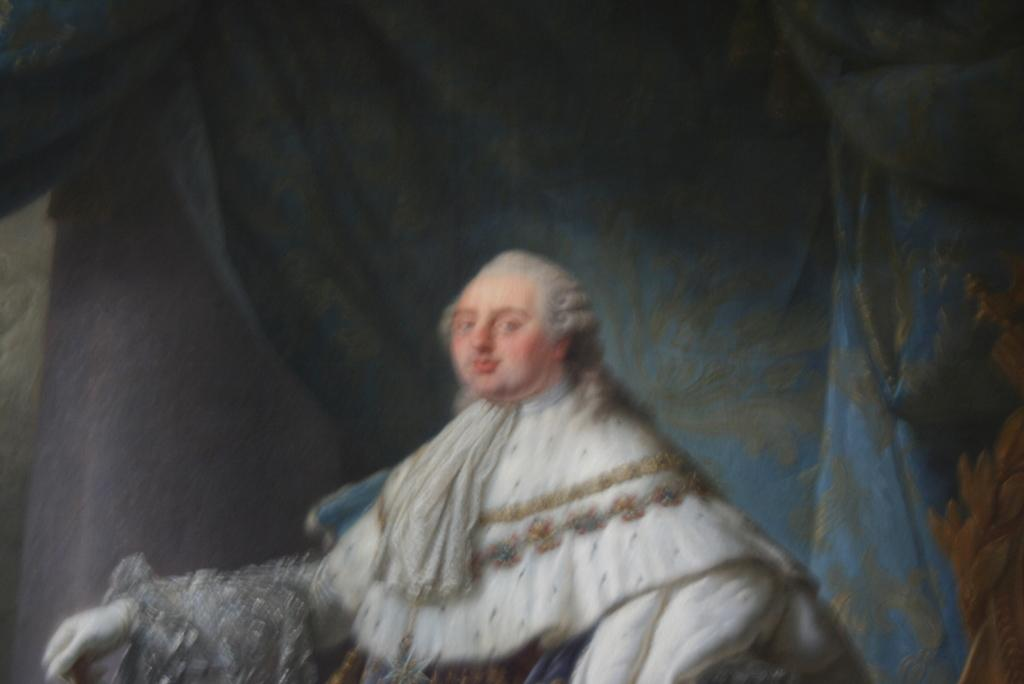What is the overall quality of the image? The image is blurry. What can be seen in the image despite the blurriness? There is a statue of a person in the image. What is visible in the background of the image? There are curtains in the background of the image. What type of toothpaste is the statue using in the image? There is no toothpaste present in the image, and the statue is not using any toothpaste. 